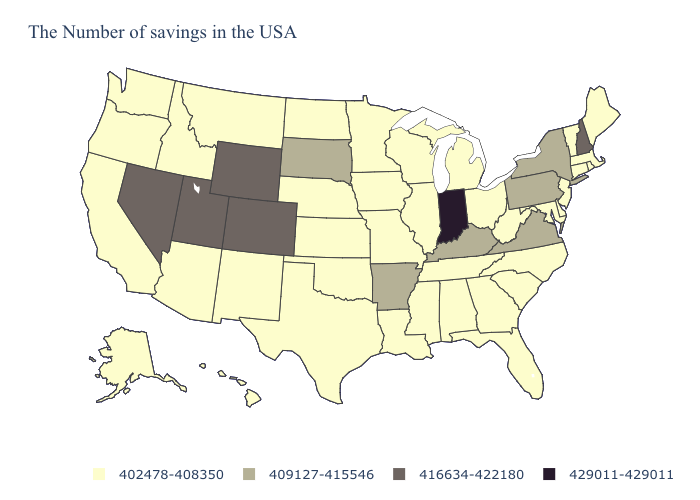Does New York have the lowest value in the Northeast?
Short answer required. No. Name the states that have a value in the range 416634-422180?
Be succinct. New Hampshire, Wyoming, Colorado, Utah, Nevada. Does the first symbol in the legend represent the smallest category?
Keep it brief. Yes. Does the map have missing data?
Give a very brief answer. No. Name the states that have a value in the range 416634-422180?
Keep it brief. New Hampshire, Wyoming, Colorado, Utah, Nevada. What is the highest value in the USA?
Short answer required. 429011-429011. Among the states that border Illinois , does Missouri have the highest value?
Answer briefly. No. What is the value of New Hampshire?
Write a very short answer. 416634-422180. What is the value of Mississippi?
Answer briefly. 402478-408350. Among the states that border Rhode Island , which have the highest value?
Answer briefly. Massachusetts, Connecticut. Does Florida have a lower value than Arizona?
Write a very short answer. No. What is the value of Idaho?
Concise answer only. 402478-408350. What is the value of Virginia?
Be succinct. 409127-415546. What is the lowest value in the USA?
Quick response, please. 402478-408350. Name the states that have a value in the range 429011-429011?
Give a very brief answer. Indiana. 